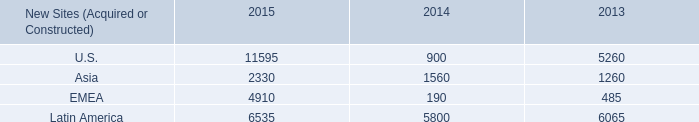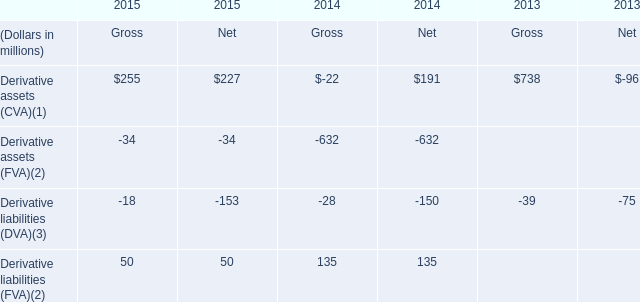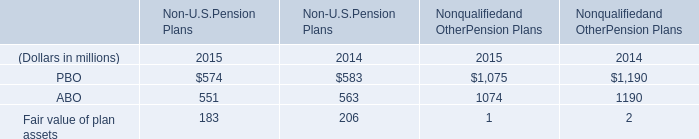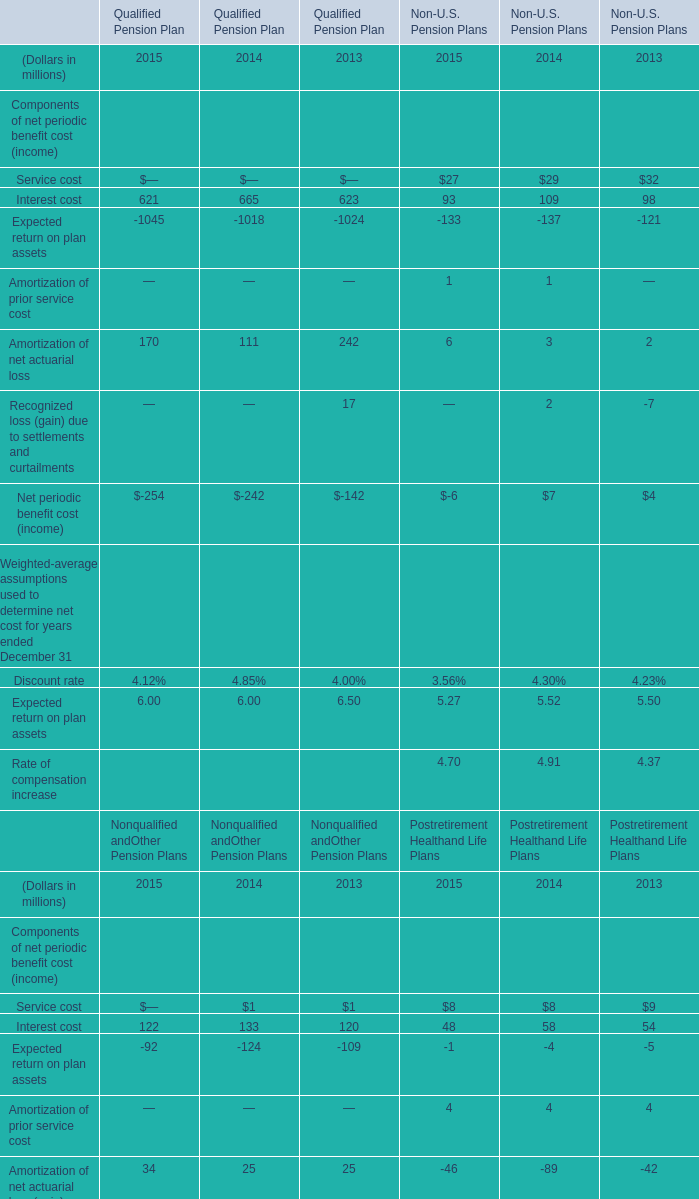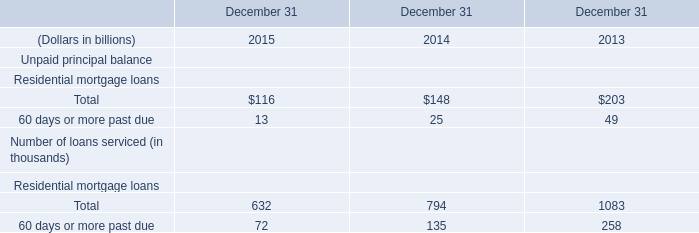What is the growing rate of PBO in the years with the least ABO? (in million) 
Computations: ((574 - 583) / 583)
Answer: -0.01544. 